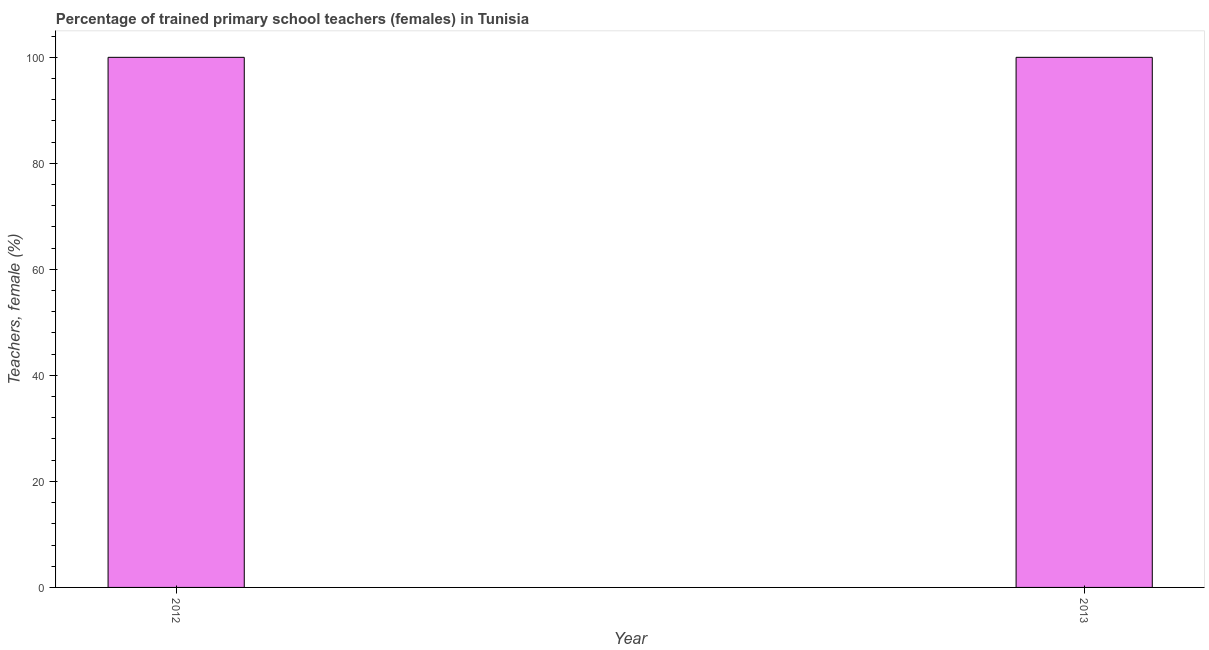Does the graph contain any zero values?
Your response must be concise. No. Does the graph contain grids?
Your answer should be compact. No. What is the title of the graph?
Keep it short and to the point. Percentage of trained primary school teachers (females) in Tunisia. What is the label or title of the Y-axis?
Your answer should be very brief. Teachers, female (%). What is the percentage of trained female teachers in 2013?
Your response must be concise. 100. In which year was the percentage of trained female teachers minimum?
Offer a terse response. 2012. What is the sum of the percentage of trained female teachers?
Your answer should be compact. 200. What is the average percentage of trained female teachers per year?
Offer a terse response. 100. What is the ratio of the percentage of trained female teachers in 2012 to that in 2013?
Your answer should be very brief. 1. How many bars are there?
Give a very brief answer. 2. Are all the bars in the graph horizontal?
Provide a short and direct response. No. Are the values on the major ticks of Y-axis written in scientific E-notation?
Your answer should be compact. No. What is the Teachers, female (%) in 2012?
Provide a succinct answer. 100. What is the ratio of the Teachers, female (%) in 2012 to that in 2013?
Give a very brief answer. 1. 